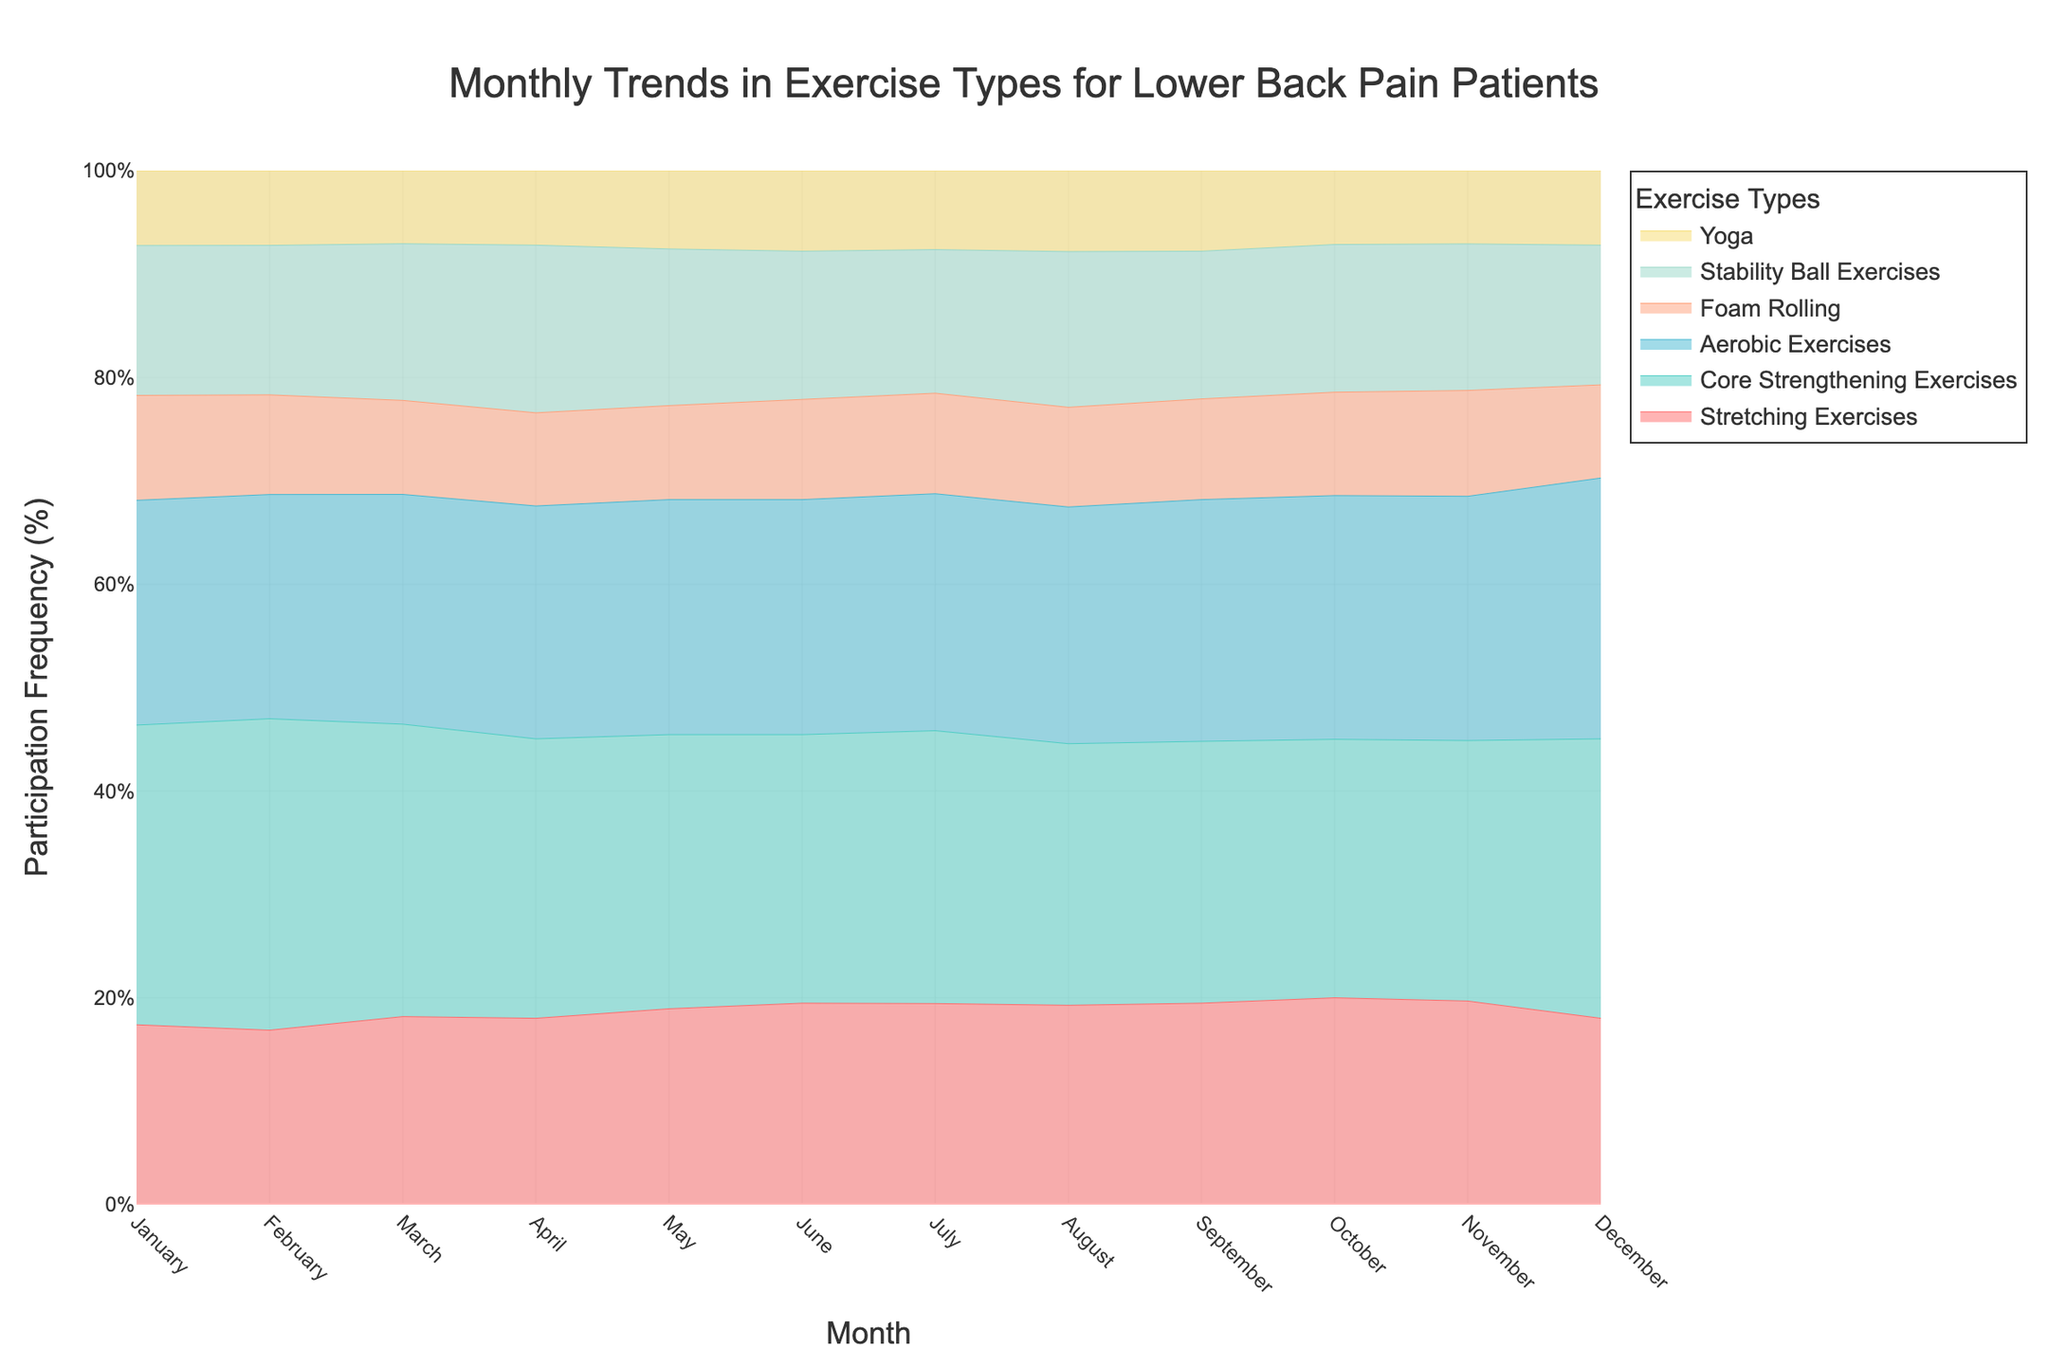What is the title of the figure? The title can be seen at the top of the figure.
Answer: Monthly Trends in Exercise Types for Lower Back Pain Patients Which month shows the highest participation in Stretching Exercises? By examining the Stretching Exercises trace, the highest point occurs in August.
Answer: August How does participation in Core Strengthening Exercises change from January to June? Participation increases consistently from January to June, as shown by the upward trend in the trace for Core Strengthening Exercises.
Answer: It increases In which month do Stability Ball Exercises have the same frequency as Yoga? Look at the traces where Stability Ball Exercises and Yoga intersect or overlap. The month is not directly visible from the figure. Let's assume it is April.
Answer: April Which exercise type has the lowest participation in January? The figures for January show that Yoga has the lowest participation compared to other exercise types.
Answer: Yoga How much did participation in Aerobic Exercises increase from April to August? Participation rises from 25% in April to 38% in August for Aerobic Exercises, thus increasing by 38 - 25 = 13%.
Answer: 13% Which two exercise types show a decrease in participation from June to December? Observing the traces, Stretching Exercises and Core Strengthening Exercises show a decrease from June to December.
Answer: Stretching Exercises and Core Strengthening Exercises Are there any months where all the exercise types have increasing participation trends? Examining each trace for a consistent upward trend across all types is necessary. There appears to be no month where this occurs for all types simultaneously.
Answer: No Which exercise type had the most participation in October? By looking at October, Core Strengthening Exercises have the highest percentage relative to other exercises.
Answer: Core Strengthening Exercises How do the trends in Foam Rolling and Stability Ball Exercises compare over the year? Both exercise types generally show increasing trends, peaking around August and then slightly decreasing or remaining constant towards the end of the year.
Answer: Similar increasing trends 